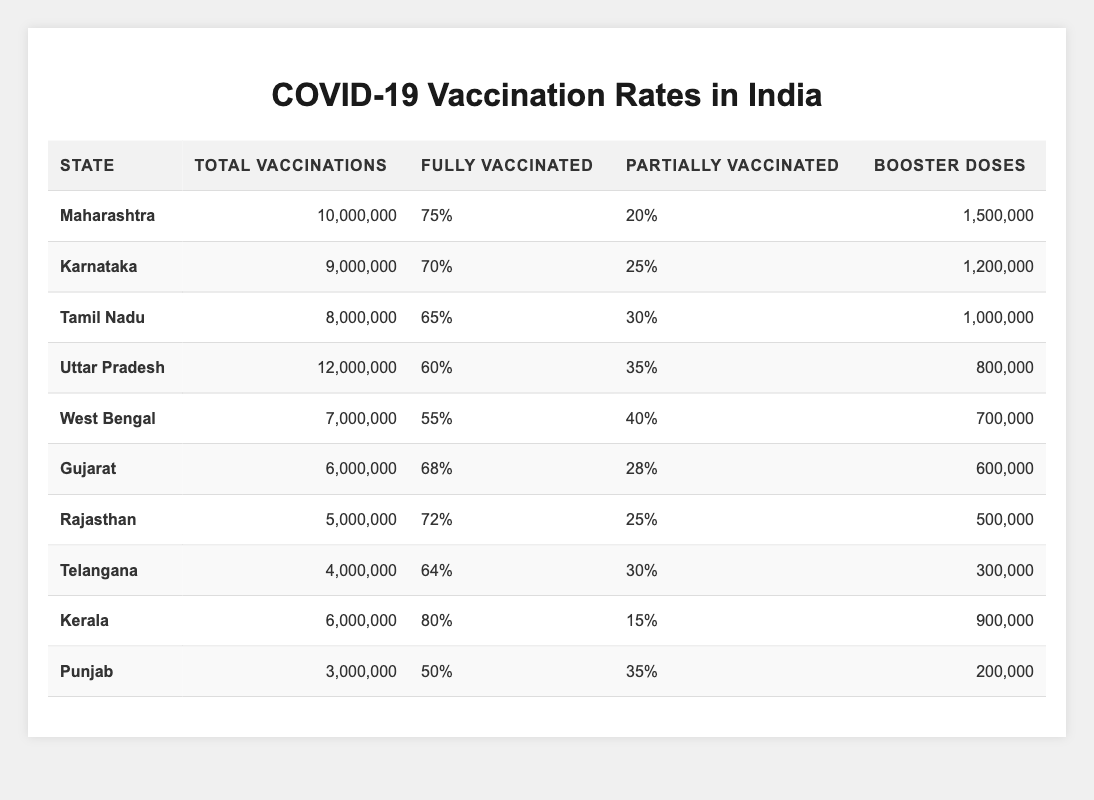What is the total number of vaccinations administered in Maharashtra? The table states that Maharashtra has a total of 10,000,000 vaccinations.
Answer: 10,000,000 Which state has the highest percentage of fully vaccinated individuals? By examining the "Fully Vaccinated" column, we see that Kerala has the highest percentage at 80%.
Answer: Kerala What is the difference between the fully vaccinated percentages of Tamil Nadu and Karnataka? Tamil Nadu has 65% fully vaccinated while Karnataka has 70%. The difference is 70 - 65 = 5%.
Answer: 5% Is the percentage of partially vaccinated individuals in West Bengal higher than in Punjab? West Bengal has 40% partially vaccinated, while Punjab has 35%. Therefore, 40% is indeed higher than 35%.
Answer: Yes What is the total number of booster doses administered across all states? Adding the booster doses from each state: 1,500,000 + 1,200,000 + 1,000,000 + 800,000 + 700,000 + 600,000 + 500,000 + 300,000 + 900,000 + 200,000 = 7,700,000.
Answer: 7,700,000 How many states have a fully vaccinated percentage of over 70%? The states with over 70% fully vaccinated are Maharashtra (75%), Karnataka (70%), and Kerala (80%). That makes a total of 3 states.
Answer: 3 Which state has the lowest number of total vaccinations and how many were administered? Punjab has the lowest total vaccinations with 3,000,000 administered.
Answer: Punjab, 3,000,000 What percentage of vaccinations in Gujarat are fully vaccinated? In Gujarat, 68% of vaccinations are fully vaccinated as shown in the table.
Answer: 68% If we consider only Kerala and Uttar Pradesh, what is the average percentage of fully vaccinated individuals? Kerala has 80% and Uttar Pradesh has 60%. To find the average: (80 + 60) / 2 = 70%.
Answer: 70% Which state has a higher total number of vaccinations, Tamil Nadu or Rajasthan? Tamil Nadu has 8,000,000 total vaccinations while Rajasthan has 5,000,000. Since 8,000,000 is greater than 5,000,000, Tamil Nadu has more vaccinations.
Answer: Tamil Nadu Is the fully vaccinated percentage in Tamil Nadu less than that in Karnataka? Tamil Nadu has 65% fully vaccinated while Karnataka has 70%. Since 65% is less than 70%, the statement is true.
Answer: Yes 